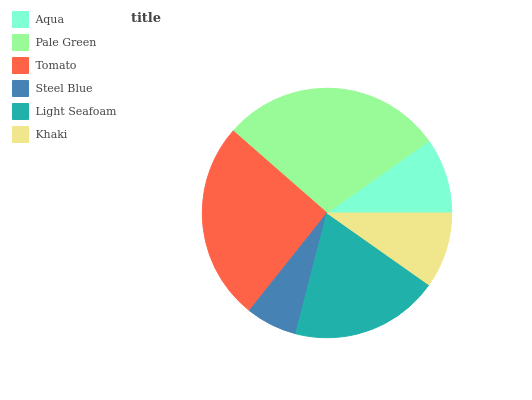Is Steel Blue the minimum?
Answer yes or no. Yes. Is Pale Green the maximum?
Answer yes or no. Yes. Is Tomato the minimum?
Answer yes or no. No. Is Tomato the maximum?
Answer yes or no. No. Is Pale Green greater than Tomato?
Answer yes or no. Yes. Is Tomato less than Pale Green?
Answer yes or no. Yes. Is Tomato greater than Pale Green?
Answer yes or no. No. Is Pale Green less than Tomato?
Answer yes or no. No. Is Light Seafoam the high median?
Answer yes or no. Yes. Is Aqua the low median?
Answer yes or no. Yes. Is Tomato the high median?
Answer yes or no. No. Is Pale Green the low median?
Answer yes or no. No. 